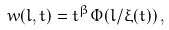<formula> <loc_0><loc_0><loc_500><loc_500>w ( l , t ) = t ^ { \beta } \Phi ( l / \xi ( t ) ) \, ,</formula> 